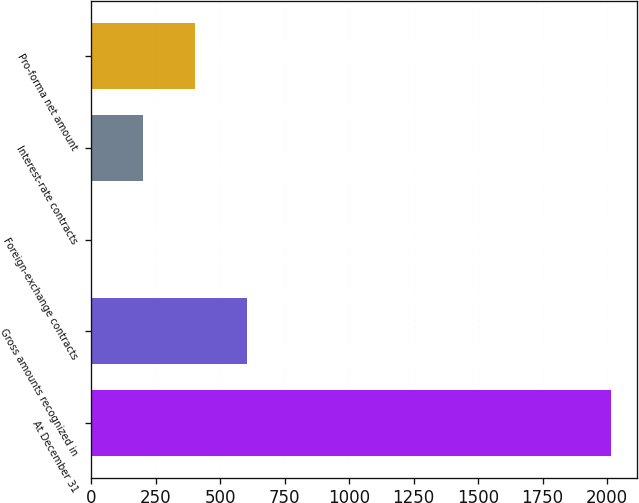<chart> <loc_0><loc_0><loc_500><loc_500><bar_chart><fcel>At December 31<fcel>Gross amounts recognized in<fcel>Foreign-exchange contracts<fcel>Interest-rate contracts<fcel>Pro-forma net amount<nl><fcel>2015<fcel>604.78<fcel>0.4<fcel>201.86<fcel>403.32<nl></chart> 